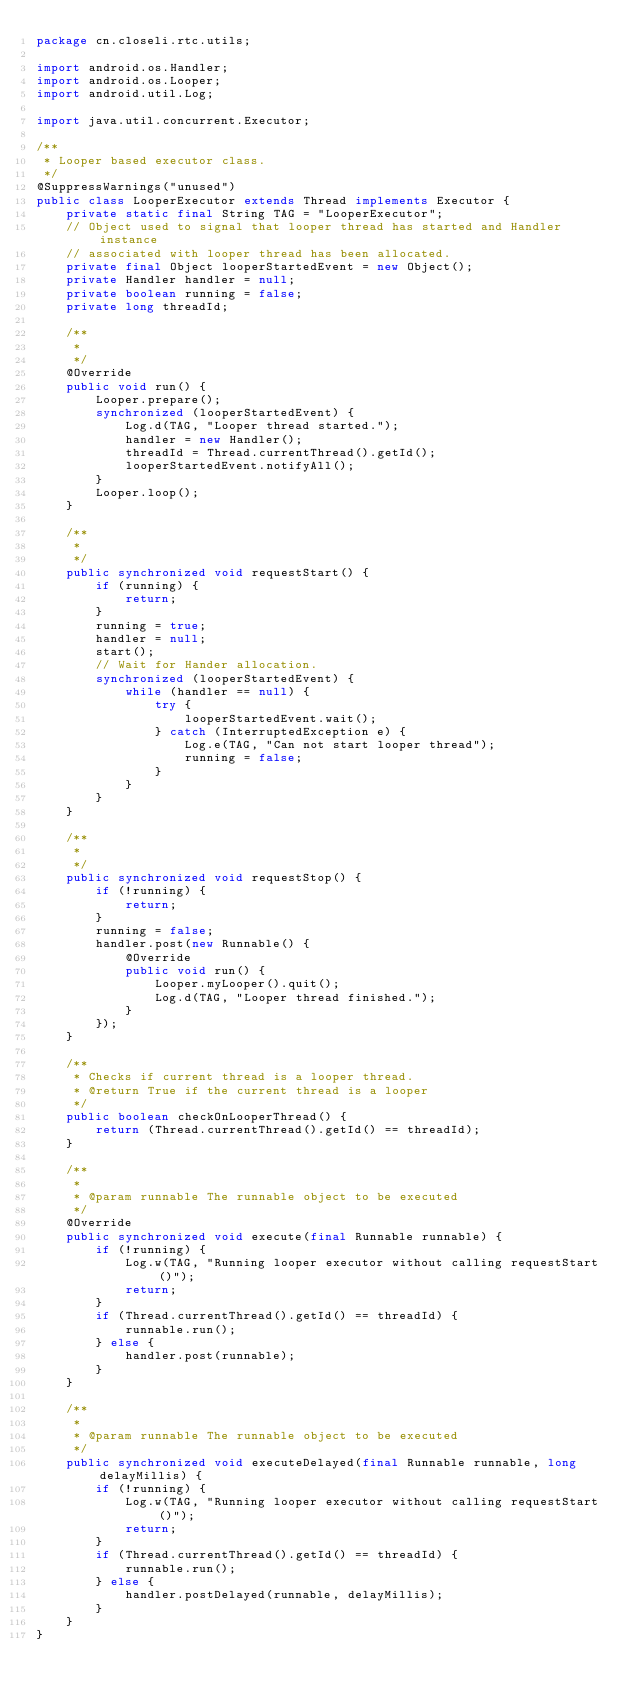<code> <loc_0><loc_0><loc_500><loc_500><_Java_>package cn.closeli.rtc.utils;

import android.os.Handler;
import android.os.Looper;
import android.util.Log;

import java.util.concurrent.Executor;

/**
 * Looper based executor class.
 */
@SuppressWarnings("unused")
public class LooperExecutor extends Thread implements Executor {
    private static final String TAG = "LooperExecutor";
    // Object used to signal that looper thread has started and Handler instance
    // associated with looper thread has been allocated.
    private final Object looperStartedEvent = new Object();
    private Handler handler = null;
    private boolean running = false;
    private long threadId;

    /**
     *
     */
    @Override
    public void run() {
        Looper.prepare();
        synchronized (looperStartedEvent) {
            Log.d(TAG, "Looper thread started.");
            handler = new Handler();
            threadId = Thread.currentThread().getId();
            looperStartedEvent.notifyAll();
        }
        Looper.loop();
    }

    /**
     *
     */
    public synchronized void requestStart() {
        if (running) {
            return;
        }
        running = true;
        handler = null;
        start();
        // Wait for Hander allocation.
        synchronized (looperStartedEvent) {
            while (handler == null) {
                try {
                    looperStartedEvent.wait();
                } catch (InterruptedException e) {
                    Log.e(TAG, "Can not start looper thread");
                    running = false;
                }
            }
        }
    }

    /**
     *
     */
    public synchronized void requestStop() {
        if (!running) {
            return;
        }
        running = false;
        handler.post(new Runnable() {
            @Override
            public void run() {
                Looper.myLooper().quit();
                Log.d(TAG, "Looper thread finished.");
            }
        });
    }

    /**
     * Checks if current thread is a looper thread.
     * @return True if the current thread is a looper
     */
    public boolean checkOnLooperThread() {
        return (Thread.currentThread().getId() == threadId);
    }

    /**
     *
     * @param runnable The runnable object to be executed
     */
    @Override
    public synchronized void execute(final Runnable runnable) {
        if (!running) {
            Log.w(TAG, "Running looper executor without calling requestStart()");
            return;
        }
        if (Thread.currentThread().getId() == threadId) {
            runnable.run();
        } else {
            handler.post(runnable);
        }
    }

    /**
     *
     * @param runnable The runnable object to be executed
     */
    public synchronized void executeDelayed(final Runnable runnable, long delayMillis) {
        if (!running) {
            Log.w(TAG, "Running looper executor without calling requestStart()");
            return;
        }
        if (Thread.currentThread().getId() == threadId) {
            runnable.run();
        } else {
            handler.postDelayed(runnable, delayMillis);
        }
    }
}
</code> 